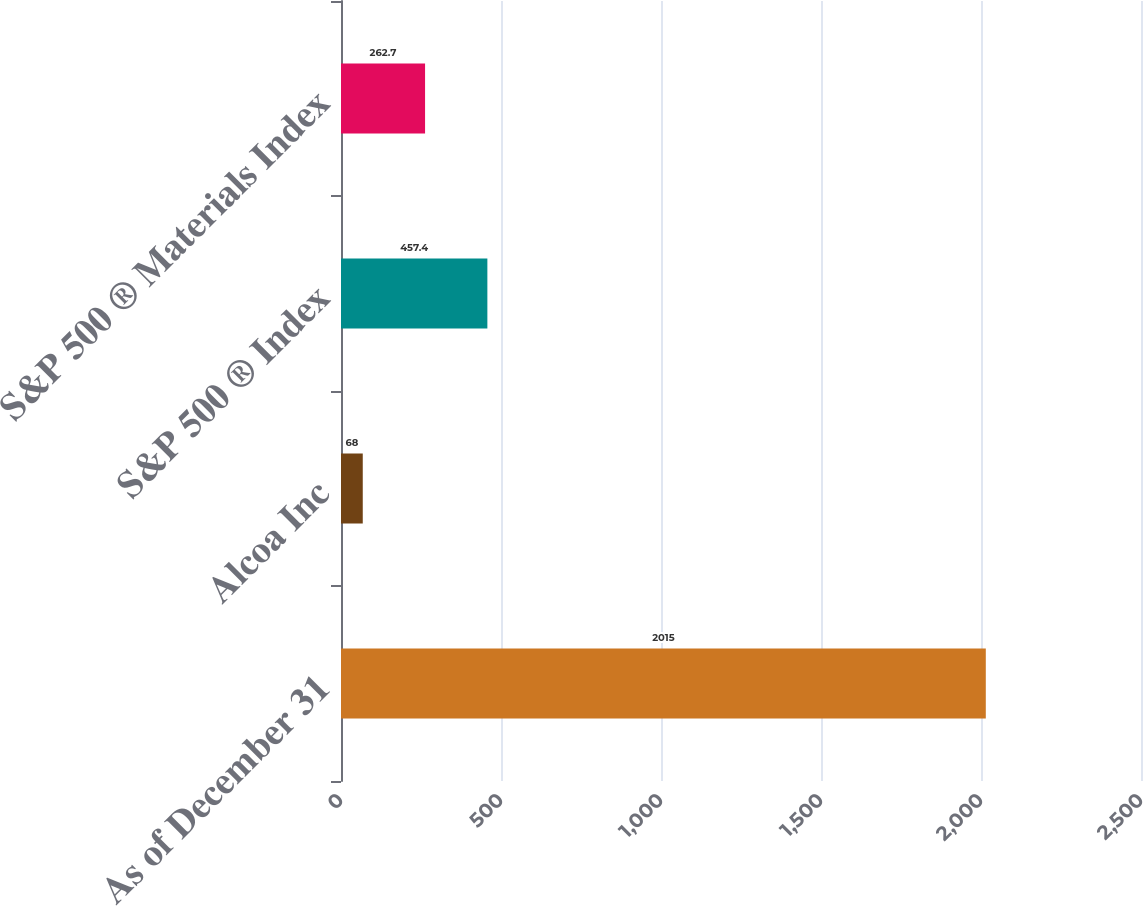<chart> <loc_0><loc_0><loc_500><loc_500><bar_chart><fcel>As of December 31<fcel>Alcoa Inc<fcel>S&P 500 ® Index<fcel>S&P 500 ® Materials Index<nl><fcel>2015<fcel>68<fcel>457.4<fcel>262.7<nl></chart> 